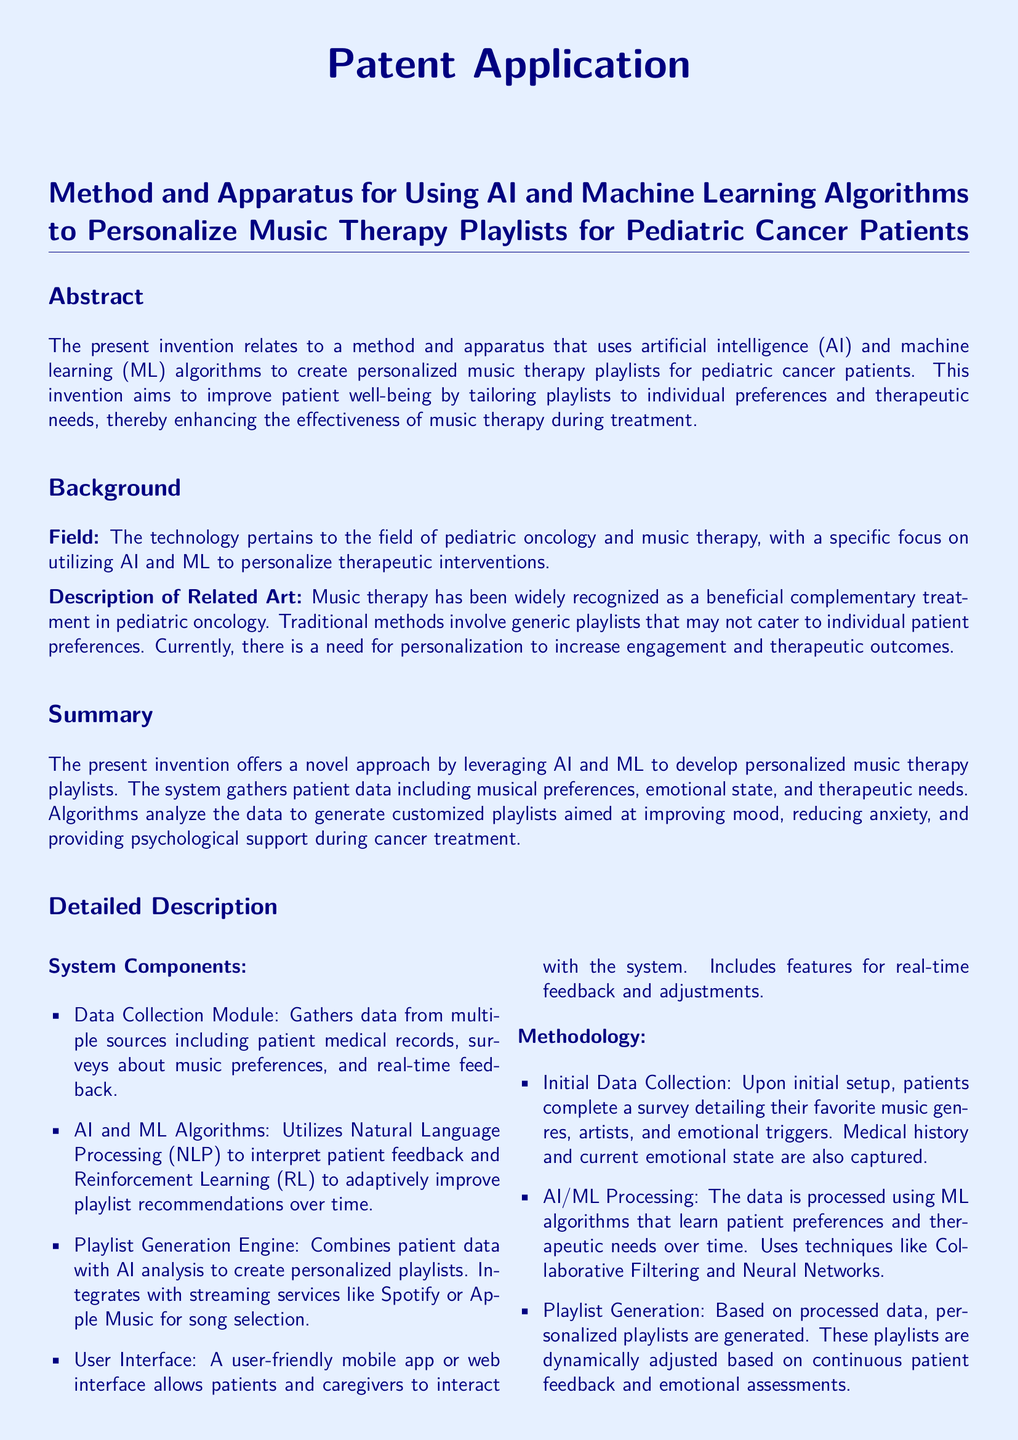What is the invention about? The invention relates to a method and apparatus that uses AI and ML algorithms to create personalized music therapy playlists for pediatric cancer patients.
Answer: Personalized music therapy playlists for pediatric cancer patients What technology does the system utilize? The technology utilizes artificial intelligence and machine learning to personalize therapeutic interventions for music therapy.
Answer: Artificial intelligence and machine learning What is the goal of the invention? The goal is to improve patient well-being by tailoring playlists to individual preferences and therapeutic needs.
Answer: Improve patient well-being How does the system gather patient data? The system gathers data from multiple sources including medical records, music preference surveys, and real-time feedback from patients.
Answer: Medical records, music preference surveys, and real-time feedback What method does the AI use to learn patient preferences? The AI uses machine learning algorithms, including Collaborative Filtering and Neural Networks, to learn patient preferences over time.
Answer: Collaborative Filtering and Neural Networks What does the feedback loop allow patients to do? The feedback loop allows patients to rate songs and playlists, providing data for further algorithmic improvements.
Answer: Rate songs and playlists What type of interface does the system provide? The system provides a user-friendly mobile app or web interface for patients and caregivers.
Answer: Mobile app or web interface How many claims are outlined in the patent? The patent outlines four claims in total regarding the method and apparatus for personalized music therapy.
Answer: Four claims Which programming language is used for AI/ML algorithms? The programming language used for AI and ML algorithms is Python.
Answer: Python 